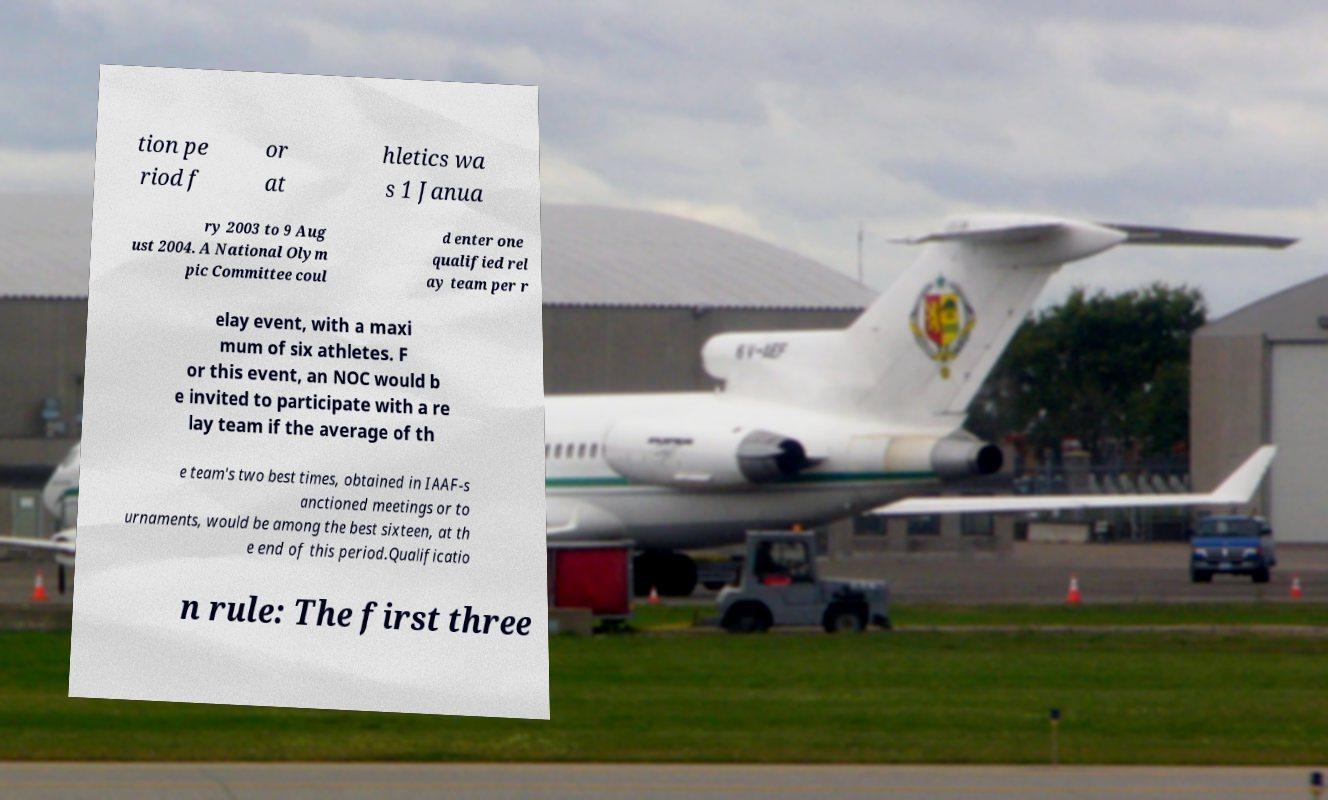For documentation purposes, I need the text within this image transcribed. Could you provide that? tion pe riod f or at hletics wa s 1 Janua ry 2003 to 9 Aug ust 2004. A National Olym pic Committee coul d enter one qualified rel ay team per r elay event, with a maxi mum of six athletes. F or this event, an NOC would b e invited to participate with a re lay team if the average of th e team's two best times, obtained in IAAF-s anctioned meetings or to urnaments, would be among the best sixteen, at th e end of this period.Qualificatio n rule: The first three 